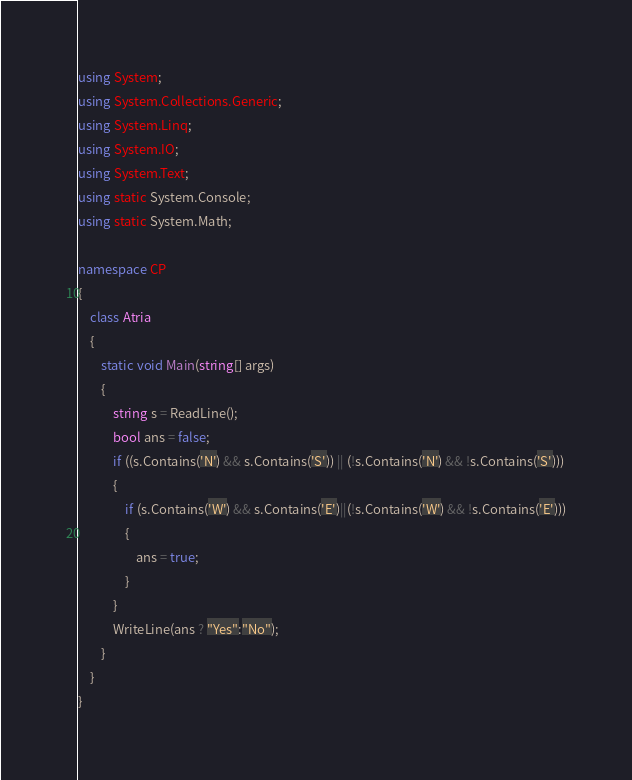<code> <loc_0><loc_0><loc_500><loc_500><_C#_>using System;
using System.Collections.Generic;
using System.Linq;
using System.IO;
using System.Text;
using static System.Console;
using static System.Math;

namespace CP
{
    class Atria
    {
        static void Main(string[] args)
        {
            string s = ReadLine();
            bool ans = false;
            if ((s.Contains('N') && s.Contains('S')) || (!s.Contains('N') && !s.Contains('S')))
            {
                if (s.Contains('W') && s.Contains('E')||(!s.Contains('W') && !s.Contains('E')))
                {
                    ans = true;
                }
            }
            WriteLine(ans ? "Yes":"No");
        }
    }
}
</code> 